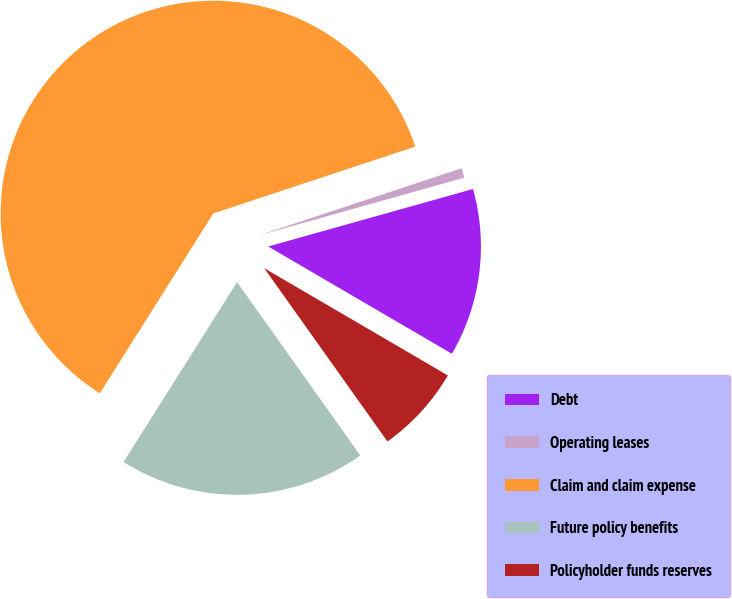Convert chart to OTSL. <chart><loc_0><loc_0><loc_500><loc_500><pie_chart><fcel>Debt<fcel>Operating leases<fcel>Claim and claim expense<fcel>Future policy benefits<fcel>Policyholder funds reserves<nl><fcel>12.77%<fcel>0.73%<fcel>60.96%<fcel>18.8%<fcel>6.75%<nl></chart> 